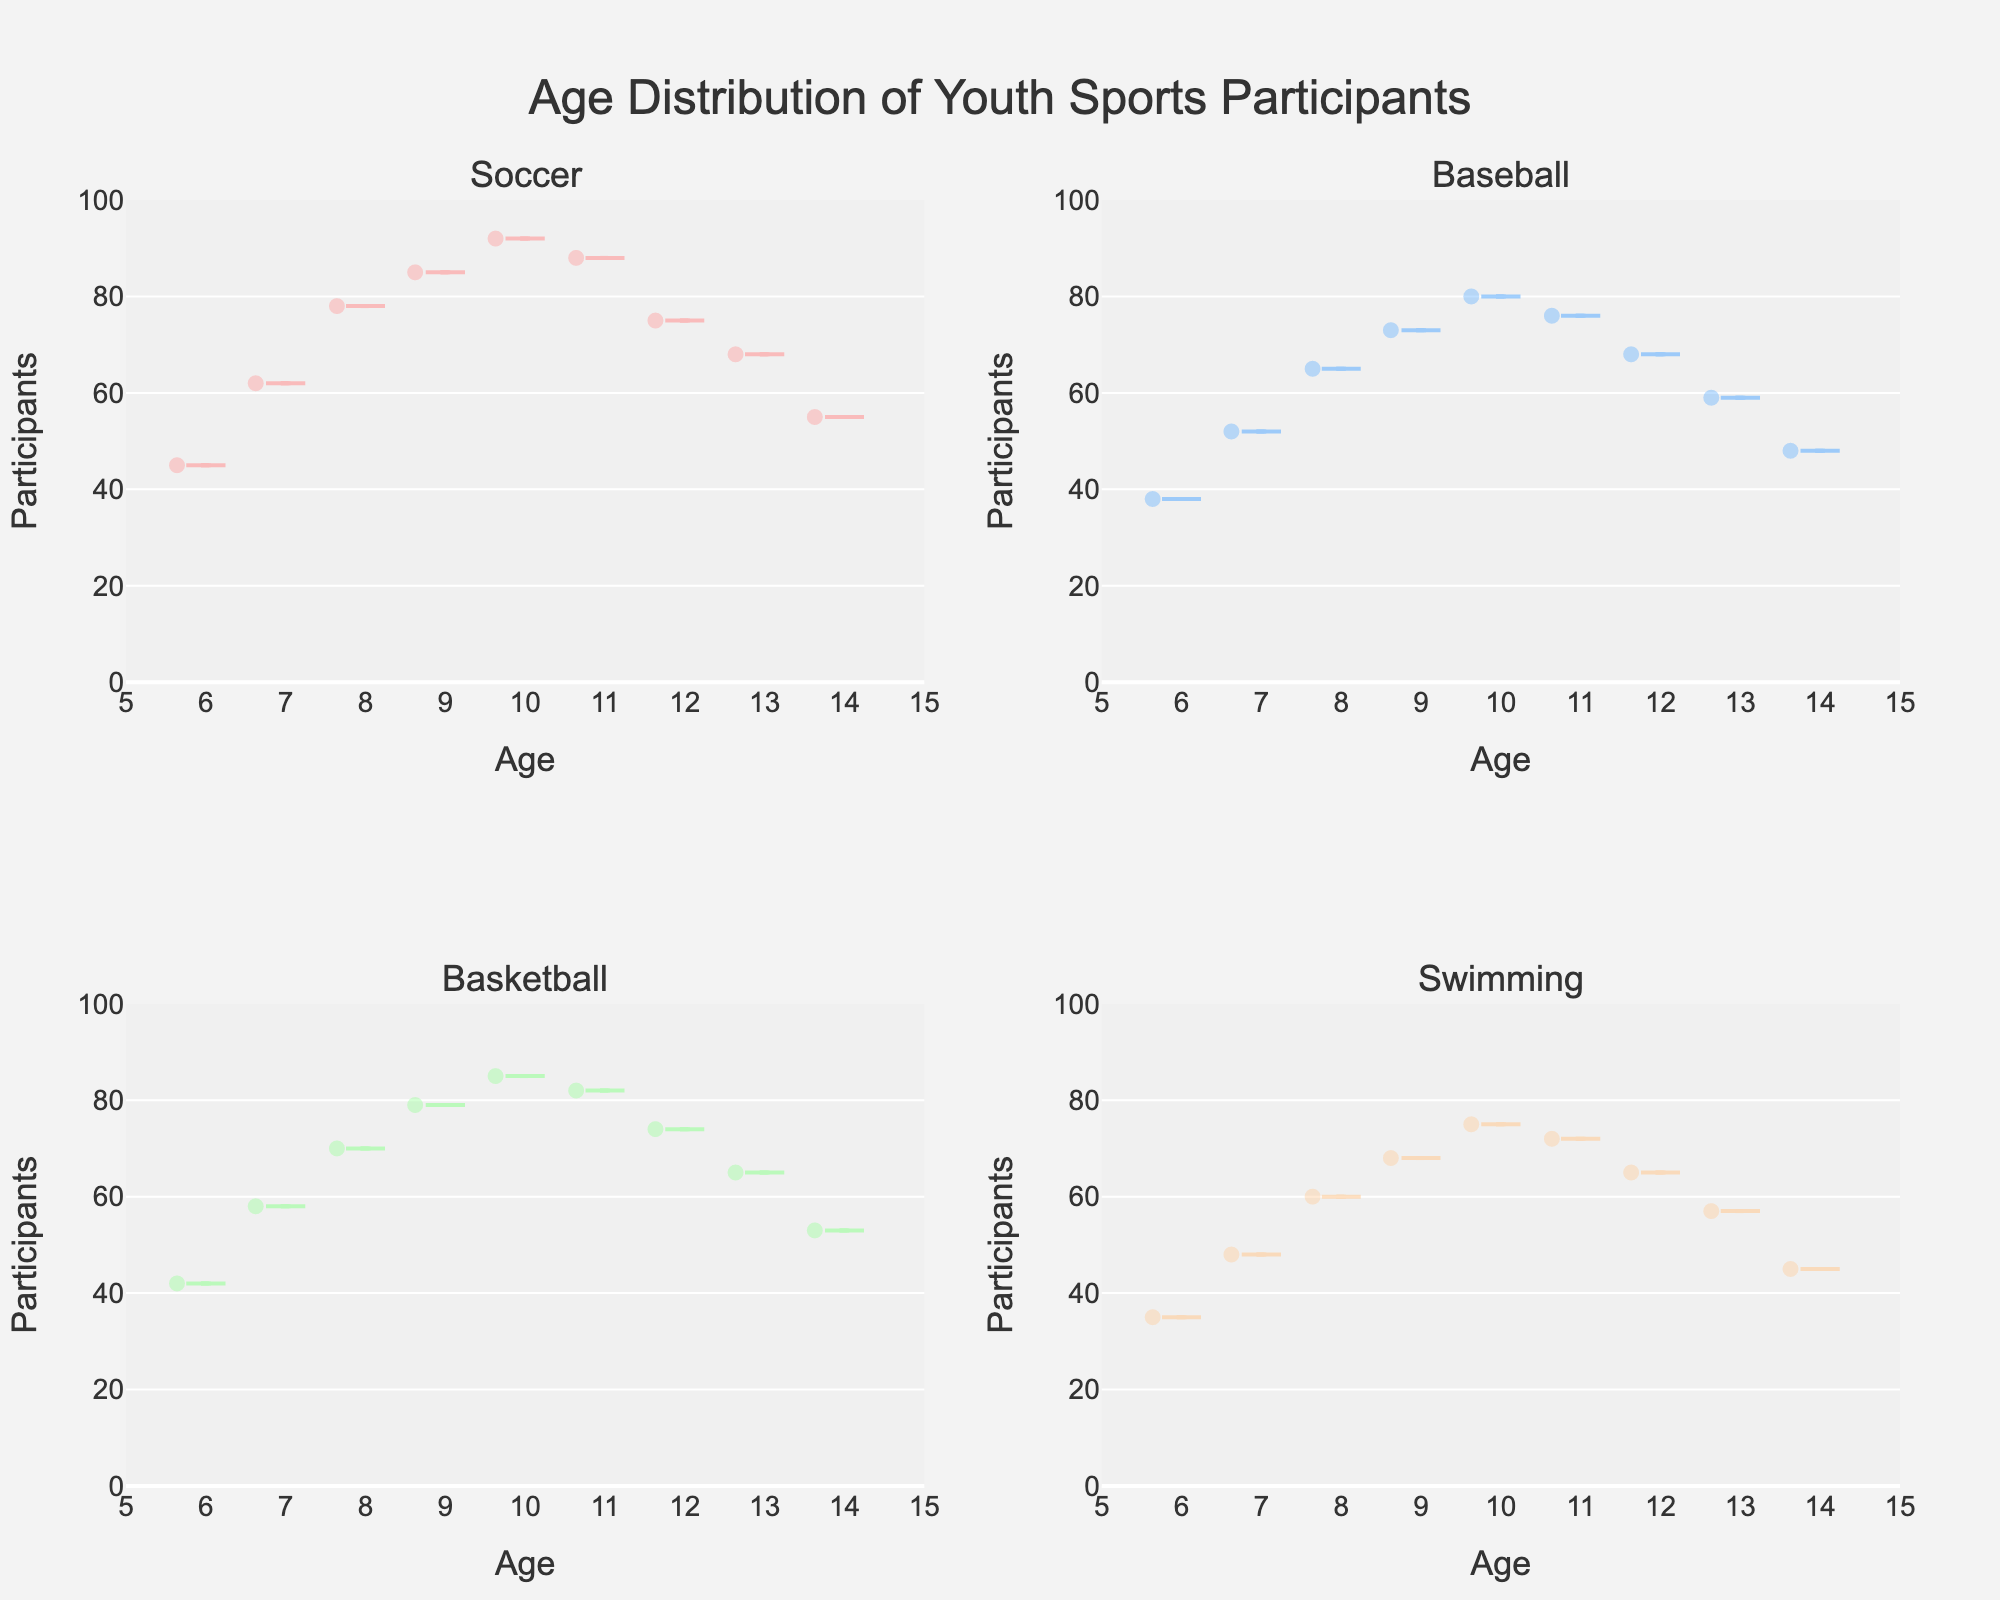What is the title of the figure? The title is usually placed at the top of the figure, summarizing the main content. Here, it shows "Age Distribution of Youth Sports Participants".
Answer: Age Distribution of Youth Sports Participants Which sport has the highest peak in participant numbers for the age group 10 years old? By looking at each subplot, we can identify that Soccer has a participant number of 92 at age 10, which is higher than any other sport for that age group.
Answer: Soccer How many participants were there in Soccer at age 6? By examining the Soccer subplot, we can see that the participant count at age 6 is marked as 45.
Answer: 45 Which sport shows the most uniform distribution of participants across different age groups? By observing the density plots, we notice that Basketball has a relatively smooth and less varied participant distribution across the different age groups. The participant numbers do not display significant peaks or troughs.
Answer: Basketball At which age does Baseball have the highest number of participants? By finding the highest point on the density plot for Baseball, we see that age 10 has the tallest point, indicating 80 participants.
Answer: 10 Compare the number of participants aged 13 and 14 in Swimming. Which age group has more participants? The Swimming subplot shows that the participant count for age 13 is 57, whereas for age 14, it is 45. Thus, age 13 has more participants.
Answer: Age 13 What is the difference in participant numbers between age 12 and age 14 in Soccer? In Soccer, the subplot shows that participant numbers for age 12 are 75 while for age 14, it is 55. The difference is 75 - 55 = 20.
Answer: 20 What is the average number of participants for ages 11 and 12 in Basketball? In the Basketball subplot, the participant numbers for ages 11 and 12 are 82 and 74 respectively. The average is (82 + 74) / 2 = 78.
Answer: 78 In which sport do we see the greatest decline in participant numbers from age 13 to 14? By comparing the decline in the different subplots, Baseball sees a significant drop from 59 participants at age 13 to 48 at age 14, a decline of 11 participants.
Answer: Baseball What is the highest number of participants recorded in any sport and age group? Reviewing all subplots, the highest number of participants recorded is in Soccer for the age group 10, with a count of 92 participants.
Answer: 92 